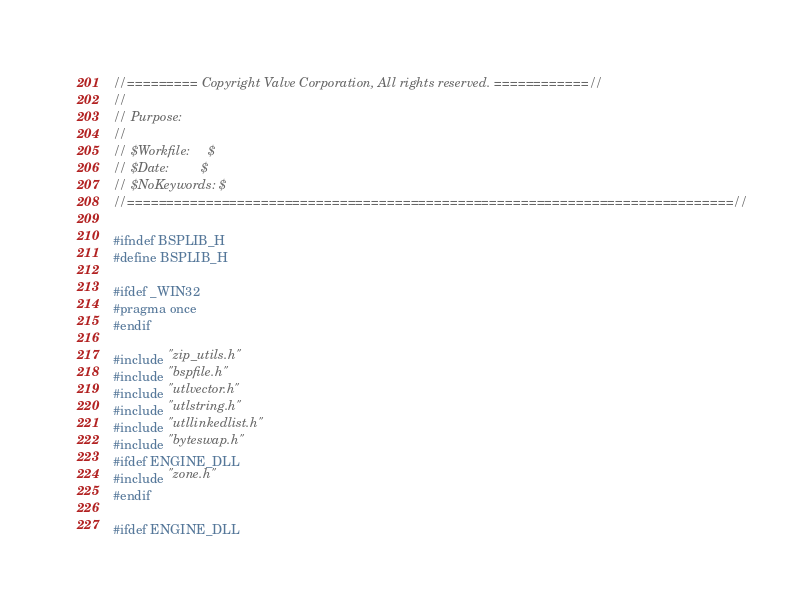<code> <loc_0><loc_0><loc_500><loc_500><_C_>//========= Copyright Valve Corporation, All rights reserved. ============//
//
// Purpose: 
//
// $Workfile:     $
// $Date:         $
// $NoKeywords: $
//=============================================================================//

#ifndef BSPLIB_H
#define BSPLIB_H

#ifdef _WIN32
#pragma once
#endif

#include "zip_utils.h"
#include "bspfile.h"
#include "utlvector.h"
#include "utlstring.h"
#include "utllinkedlist.h"
#include "byteswap.h"
#ifdef ENGINE_DLL
#include "zone.h"
#endif

#ifdef ENGINE_DLL</code> 